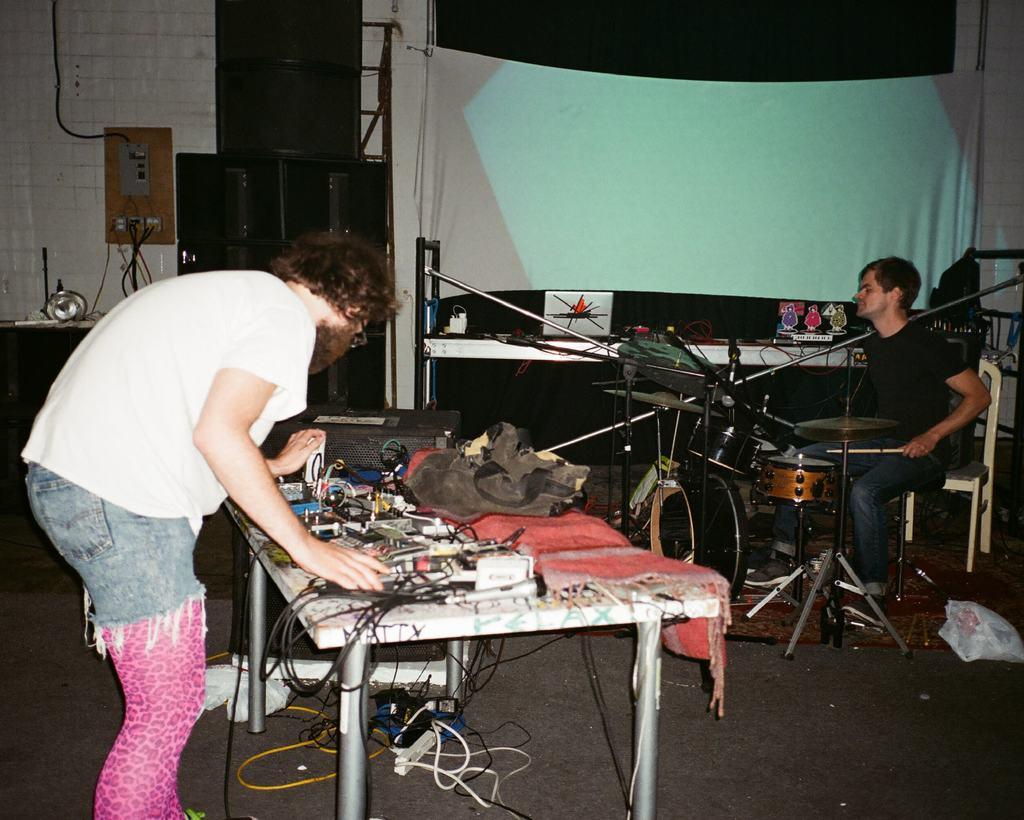How many men are present in the image? There are two men in the image, one standing and one sitting. What is the sitting man doing in the image? The sitting man is playing drums. What object can be seen near the men in the image? There is a bag in the image. What else can be seen in the image besides the men and the bag? There are wires visible in the image, as well as machines on a table. What type of cushion is being used by the committee in the image? There is no committee or cushion present in the image. How are the men sorting the items on the table in the image? The men are not sorting items on the table in the image; they are playing drums and standing near machines. 